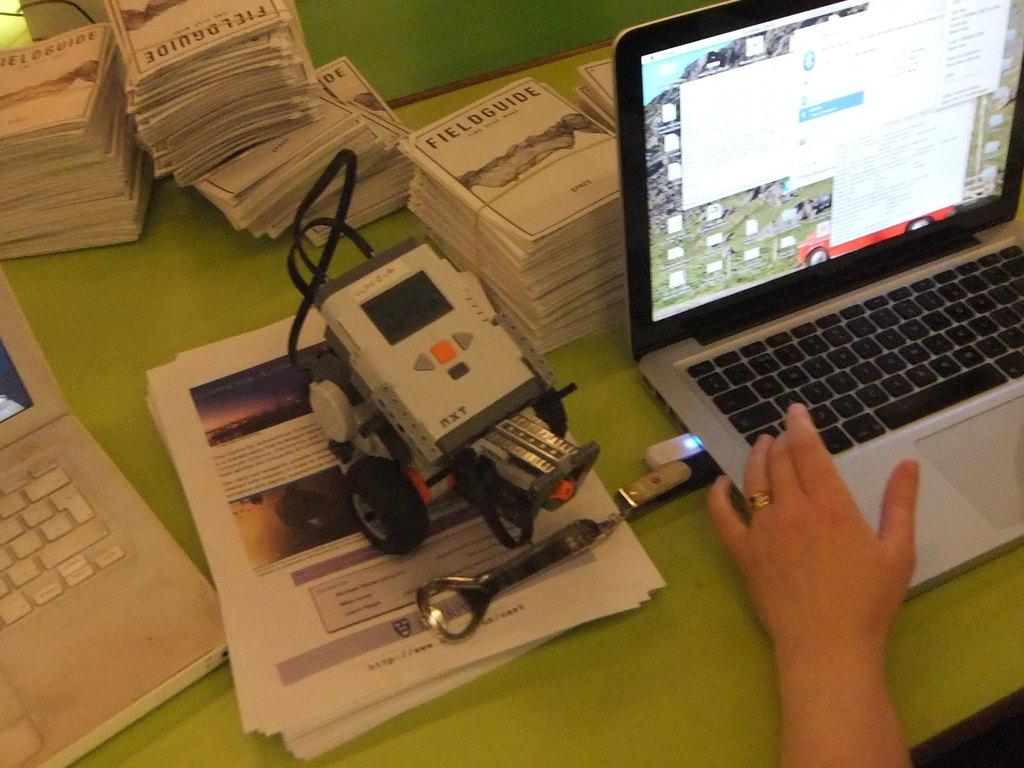What kind of guides are those?
Make the answer very short. Field. 